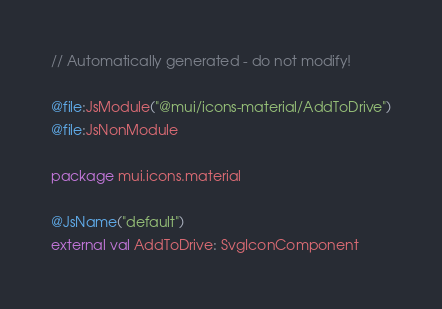Convert code to text. <code><loc_0><loc_0><loc_500><loc_500><_Kotlin_>// Automatically generated - do not modify!

@file:JsModule("@mui/icons-material/AddToDrive")
@file:JsNonModule

package mui.icons.material

@JsName("default")
external val AddToDrive: SvgIconComponent
</code> 